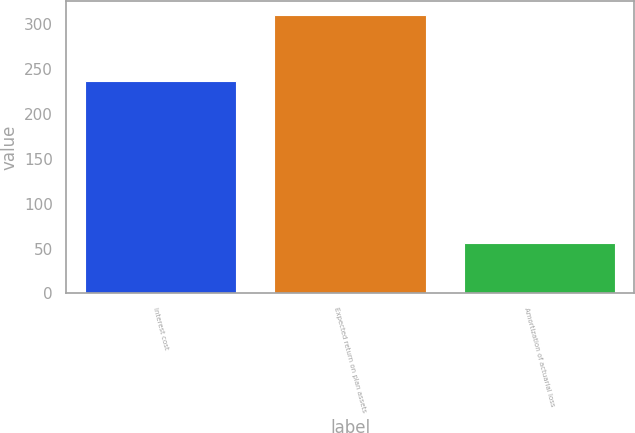<chart> <loc_0><loc_0><loc_500><loc_500><bar_chart><fcel>Interest cost<fcel>Expected return on plan assets<fcel>Amortization of actuarial loss<nl><fcel>237<fcel>311<fcel>56<nl></chart> 